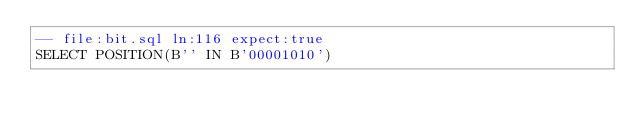<code> <loc_0><loc_0><loc_500><loc_500><_SQL_>-- file:bit.sql ln:116 expect:true
SELECT POSITION(B'' IN B'00001010')
</code> 